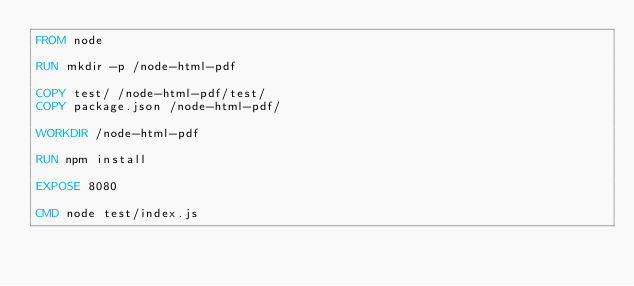Convert code to text. <code><loc_0><loc_0><loc_500><loc_500><_Dockerfile_>FROM node

RUN mkdir -p /node-html-pdf

COPY test/ /node-html-pdf/test/
COPY package.json /node-html-pdf/

WORKDIR /node-html-pdf

RUN npm install

EXPOSE 8080

CMD node test/index.js</code> 